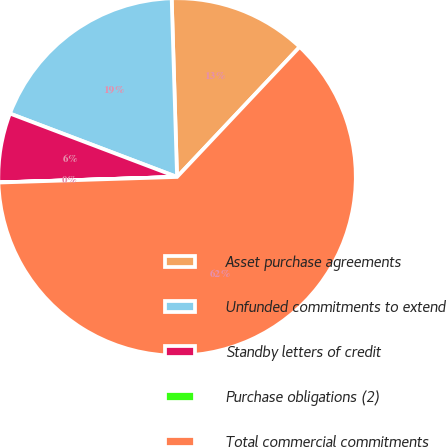Convert chart. <chart><loc_0><loc_0><loc_500><loc_500><pie_chart><fcel>Asset purchase agreements<fcel>Unfunded commitments to extend<fcel>Standby letters of credit<fcel>Purchase obligations (2)<fcel>Total commercial commitments<nl><fcel>12.51%<fcel>18.75%<fcel>6.26%<fcel>0.01%<fcel>62.47%<nl></chart> 